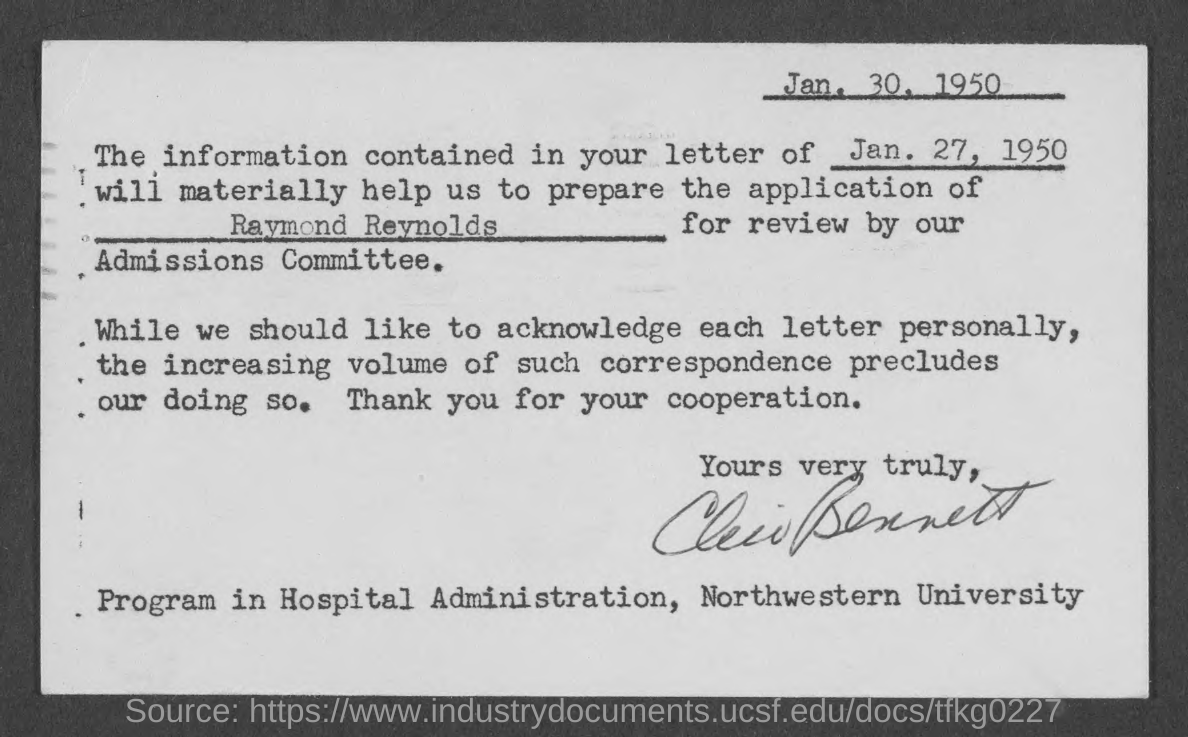Draw attention to some important aspects in this diagram. The document, dated January 30, 1950, is a declaration. 